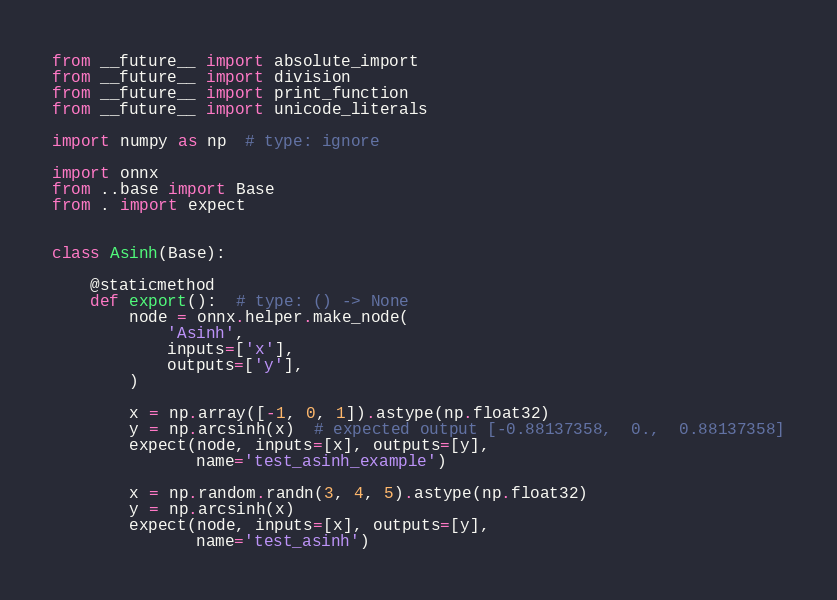Convert code to text. <code><loc_0><loc_0><loc_500><loc_500><_Python_>from __future__ import absolute_import
from __future__ import division
from __future__ import print_function
from __future__ import unicode_literals

import numpy as np  # type: ignore

import onnx
from ..base import Base
from . import expect


class Asinh(Base):

    @staticmethod
    def export():  # type: () -> None
        node = onnx.helper.make_node(
            'Asinh',
            inputs=['x'],
            outputs=['y'],
        )

        x = np.array([-1, 0, 1]).astype(np.float32)
        y = np.arcsinh(x)  # expected output [-0.88137358,  0.,  0.88137358]
        expect(node, inputs=[x], outputs=[y],
               name='test_asinh_example')

        x = np.random.randn(3, 4, 5).astype(np.float32)
        y = np.arcsinh(x)
        expect(node, inputs=[x], outputs=[y],
               name='test_asinh')
</code> 